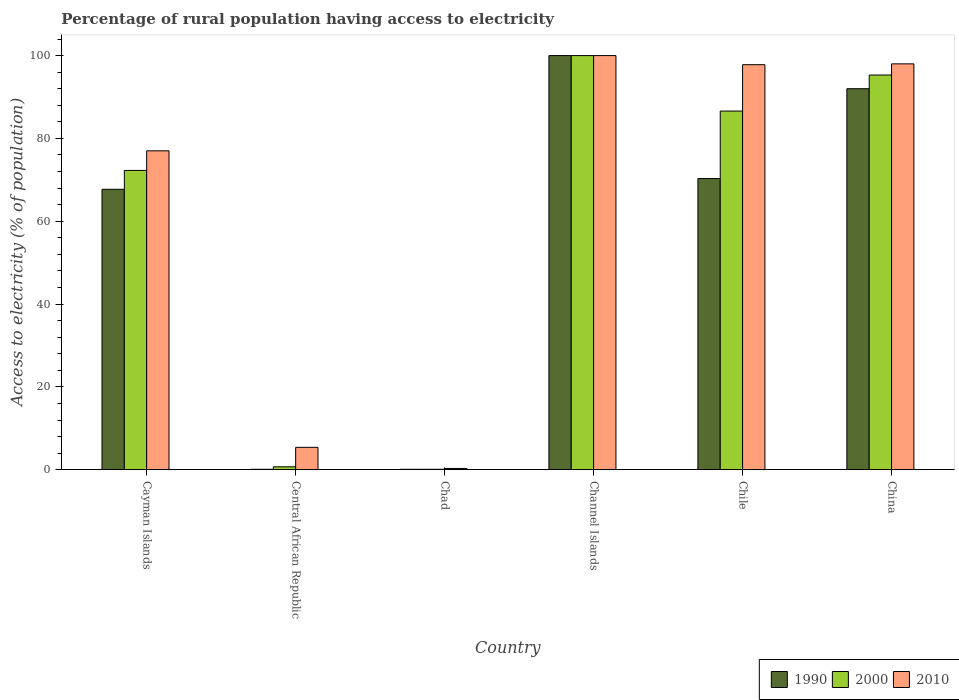How many different coloured bars are there?
Offer a very short reply. 3. How many groups of bars are there?
Make the answer very short. 6. How many bars are there on the 5th tick from the right?
Provide a succinct answer. 3. What is the label of the 1st group of bars from the left?
Keep it short and to the point. Cayman Islands. In how many cases, is the number of bars for a given country not equal to the number of legend labels?
Provide a succinct answer. 0. What is the percentage of rural population having access to electricity in 2000 in Cayman Islands?
Your response must be concise. 72.27. Across all countries, what is the maximum percentage of rural population having access to electricity in 2010?
Ensure brevity in your answer.  100. Across all countries, what is the minimum percentage of rural population having access to electricity in 2000?
Provide a short and direct response. 0.1. In which country was the percentage of rural population having access to electricity in 1990 maximum?
Your answer should be compact. Channel Islands. In which country was the percentage of rural population having access to electricity in 2010 minimum?
Make the answer very short. Chad. What is the total percentage of rural population having access to electricity in 2000 in the graph?
Your answer should be very brief. 354.97. What is the difference between the percentage of rural population having access to electricity in 1990 in Chile and the percentage of rural population having access to electricity in 2010 in Cayman Islands?
Offer a very short reply. -6.7. What is the average percentage of rural population having access to electricity in 2010 per country?
Offer a very short reply. 63.08. What is the difference between the percentage of rural population having access to electricity of/in 2010 and percentage of rural population having access to electricity of/in 2000 in Chad?
Offer a terse response. 0.2. In how many countries, is the percentage of rural population having access to electricity in 2010 greater than 56 %?
Keep it short and to the point. 4. What is the ratio of the percentage of rural population having access to electricity in 2010 in Cayman Islands to that in China?
Your answer should be very brief. 0.79. Is the percentage of rural population having access to electricity in 2000 in Chad less than that in Channel Islands?
Offer a terse response. Yes. Is the difference between the percentage of rural population having access to electricity in 2010 in Chile and China greater than the difference between the percentage of rural population having access to electricity in 2000 in Chile and China?
Your response must be concise. Yes. What is the difference between the highest and the second highest percentage of rural population having access to electricity in 2000?
Your response must be concise. 13.4. What is the difference between the highest and the lowest percentage of rural population having access to electricity in 2010?
Provide a succinct answer. 99.7. In how many countries, is the percentage of rural population having access to electricity in 2010 greater than the average percentage of rural population having access to electricity in 2010 taken over all countries?
Provide a short and direct response. 4. What does the 2nd bar from the left in Chad represents?
Provide a short and direct response. 2000. Is it the case that in every country, the sum of the percentage of rural population having access to electricity in 1990 and percentage of rural population having access to electricity in 2000 is greater than the percentage of rural population having access to electricity in 2010?
Make the answer very short. No. Does the graph contain any zero values?
Offer a very short reply. No. Where does the legend appear in the graph?
Give a very brief answer. Bottom right. What is the title of the graph?
Your response must be concise. Percentage of rural population having access to electricity. Does "1994" appear as one of the legend labels in the graph?
Your response must be concise. No. What is the label or title of the X-axis?
Provide a short and direct response. Country. What is the label or title of the Y-axis?
Offer a terse response. Access to electricity (% of population). What is the Access to electricity (% of population) of 1990 in Cayman Islands?
Your response must be concise. 67.71. What is the Access to electricity (% of population) in 2000 in Cayman Islands?
Provide a succinct answer. 72.27. What is the Access to electricity (% of population) of 2010 in Cayman Islands?
Your answer should be very brief. 77. What is the Access to electricity (% of population) in 2000 in Central African Republic?
Your answer should be very brief. 0.7. What is the Access to electricity (% of population) in 2010 in Central African Republic?
Offer a terse response. 5.4. What is the Access to electricity (% of population) of 1990 in Chad?
Make the answer very short. 0.1. What is the Access to electricity (% of population) in 2000 in Chad?
Your answer should be compact. 0.1. What is the Access to electricity (% of population) of 2010 in Chad?
Your response must be concise. 0.3. What is the Access to electricity (% of population) in 2000 in Channel Islands?
Give a very brief answer. 100. What is the Access to electricity (% of population) of 1990 in Chile?
Keep it short and to the point. 70.3. What is the Access to electricity (% of population) of 2000 in Chile?
Offer a very short reply. 86.6. What is the Access to electricity (% of population) in 2010 in Chile?
Your response must be concise. 97.8. What is the Access to electricity (% of population) in 1990 in China?
Provide a short and direct response. 92. What is the Access to electricity (% of population) of 2000 in China?
Your answer should be compact. 95.3. Across all countries, what is the maximum Access to electricity (% of population) in 2010?
Give a very brief answer. 100. Across all countries, what is the minimum Access to electricity (% of population) of 2000?
Provide a succinct answer. 0.1. Across all countries, what is the minimum Access to electricity (% of population) in 2010?
Offer a very short reply. 0.3. What is the total Access to electricity (% of population) of 1990 in the graph?
Give a very brief answer. 330.21. What is the total Access to electricity (% of population) of 2000 in the graph?
Your answer should be compact. 354.96. What is the total Access to electricity (% of population) of 2010 in the graph?
Keep it short and to the point. 378.5. What is the difference between the Access to electricity (% of population) of 1990 in Cayman Islands and that in Central African Republic?
Make the answer very short. 67.61. What is the difference between the Access to electricity (% of population) of 2000 in Cayman Islands and that in Central African Republic?
Ensure brevity in your answer.  71.56. What is the difference between the Access to electricity (% of population) in 2010 in Cayman Islands and that in Central African Republic?
Provide a succinct answer. 71.6. What is the difference between the Access to electricity (% of population) in 1990 in Cayman Islands and that in Chad?
Your answer should be compact. 67.61. What is the difference between the Access to electricity (% of population) in 2000 in Cayman Islands and that in Chad?
Offer a very short reply. 72.17. What is the difference between the Access to electricity (% of population) in 2010 in Cayman Islands and that in Chad?
Give a very brief answer. 76.7. What is the difference between the Access to electricity (% of population) of 1990 in Cayman Islands and that in Channel Islands?
Your answer should be very brief. -32.29. What is the difference between the Access to electricity (% of population) of 2000 in Cayman Islands and that in Channel Islands?
Your answer should be very brief. -27.73. What is the difference between the Access to electricity (% of population) in 2010 in Cayman Islands and that in Channel Islands?
Offer a very short reply. -23. What is the difference between the Access to electricity (% of population) of 1990 in Cayman Islands and that in Chile?
Your response must be concise. -2.59. What is the difference between the Access to electricity (% of population) in 2000 in Cayman Islands and that in Chile?
Your response must be concise. -14.34. What is the difference between the Access to electricity (% of population) in 2010 in Cayman Islands and that in Chile?
Your answer should be compact. -20.8. What is the difference between the Access to electricity (% of population) in 1990 in Cayman Islands and that in China?
Your answer should be compact. -24.29. What is the difference between the Access to electricity (% of population) of 2000 in Cayman Islands and that in China?
Provide a succinct answer. -23.04. What is the difference between the Access to electricity (% of population) of 2010 in Cayman Islands and that in China?
Make the answer very short. -21. What is the difference between the Access to electricity (% of population) of 2000 in Central African Republic and that in Chad?
Provide a succinct answer. 0.6. What is the difference between the Access to electricity (% of population) of 2010 in Central African Republic and that in Chad?
Your answer should be very brief. 5.1. What is the difference between the Access to electricity (% of population) in 1990 in Central African Republic and that in Channel Islands?
Your answer should be compact. -99.9. What is the difference between the Access to electricity (% of population) in 2000 in Central African Republic and that in Channel Islands?
Provide a short and direct response. -99.3. What is the difference between the Access to electricity (% of population) in 2010 in Central African Republic and that in Channel Islands?
Make the answer very short. -94.6. What is the difference between the Access to electricity (% of population) of 1990 in Central African Republic and that in Chile?
Offer a very short reply. -70.2. What is the difference between the Access to electricity (% of population) of 2000 in Central African Republic and that in Chile?
Ensure brevity in your answer.  -85.9. What is the difference between the Access to electricity (% of population) in 2010 in Central African Republic and that in Chile?
Your answer should be compact. -92.4. What is the difference between the Access to electricity (% of population) in 1990 in Central African Republic and that in China?
Ensure brevity in your answer.  -91.9. What is the difference between the Access to electricity (% of population) in 2000 in Central African Republic and that in China?
Ensure brevity in your answer.  -94.6. What is the difference between the Access to electricity (% of population) in 2010 in Central African Republic and that in China?
Give a very brief answer. -92.6. What is the difference between the Access to electricity (% of population) in 1990 in Chad and that in Channel Islands?
Your answer should be very brief. -99.9. What is the difference between the Access to electricity (% of population) in 2000 in Chad and that in Channel Islands?
Your answer should be compact. -99.9. What is the difference between the Access to electricity (% of population) in 2010 in Chad and that in Channel Islands?
Keep it short and to the point. -99.7. What is the difference between the Access to electricity (% of population) in 1990 in Chad and that in Chile?
Offer a terse response. -70.2. What is the difference between the Access to electricity (% of population) of 2000 in Chad and that in Chile?
Keep it short and to the point. -86.5. What is the difference between the Access to electricity (% of population) in 2010 in Chad and that in Chile?
Your response must be concise. -97.5. What is the difference between the Access to electricity (% of population) in 1990 in Chad and that in China?
Provide a succinct answer. -91.9. What is the difference between the Access to electricity (% of population) of 2000 in Chad and that in China?
Offer a terse response. -95.2. What is the difference between the Access to electricity (% of population) in 2010 in Chad and that in China?
Provide a succinct answer. -97.7. What is the difference between the Access to electricity (% of population) in 1990 in Channel Islands and that in Chile?
Your response must be concise. 29.7. What is the difference between the Access to electricity (% of population) of 2000 in Channel Islands and that in Chile?
Keep it short and to the point. 13.4. What is the difference between the Access to electricity (% of population) of 2000 in Channel Islands and that in China?
Keep it short and to the point. 4.7. What is the difference between the Access to electricity (% of population) in 2010 in Channel Islands and that in China?
Your answer should be compact. 2. What is the difference between the Access to electricity (% of population) in 1990 in Chile and that in China?
Your answer should be compact. -21.7. What is the difference between the Access to electricity (% of population) of 2000 in Chile and that in China?
Your answer should be compact. -8.7. What is the difference between the Access to electricity (% of population) in 1990 in Cayman Islands and the Access to electricity (% of population) in 2000 in Central African Republic?
Provide a short and direct response. 67.01. What is the difference between the Access to electricity (% of population) in 1990 in Cayman Islands and the Access to electricity (% of population) in 2010 in Central African Republic?
Your answer should be compact. 62.31. What is the difference between the Access to electricity (% of population) in 2000 in Cayman Islands and the Access to electricity (% of population) in 2010 in Central African Republic?
Make the answer very short. 66.86. What is the difference between the Access to electricity (% of population) in 1990 in Cayman Islands and the Access to electricity (% of population) in 2000 in Chad?
Offer a very short reply. 67.61. What is the difference between the Access to electricity (% of population) of 1990 in Cayman Islands and the Access to electricity (% of population) of 2010 in Chad?
Your answer should be compact. 67.41. What is the difference between the Access to electricity (% of population) of 2000 in Cayman Islands and the Access to electricity (% of population) of 2010 in Chad?
Make the answer very short. 71.97. What is the difference between the Access to electricity (% of population) of 1990 in Cayman Islands and the Access to electricity (% of population) of 2000 in Channel Islands?
Give a very brief answer. -32.29. What is the difference between the Access to electricity (% of population) in 1990 in Cayman Islands and the Access to electricity (% of population) in 2010 in Channel Islands?
Offer a terse response. -32.29. What is the difference between the Access to electricity (% of population) in 2000 in Cayman Islands and the Access to electricity (% of population) in 2010 in Channel Islands?
Your answer should be very brief. -27.73. What is the difference between the Access to electricity (% of population) in 1990 in Cayman Islands and the Access to electricity (% of population) in 2000 in Chile?
Keep it short and to the point. -18.89. What is the difference between the Access to electricity (% of population) of 1990 in Cayman Islands and the Access to electricity (% of population) of 2010 in Chile?
Provide a short and direct response. -30.09. What is the difference between the Access to electricity (% of population) of 2000 in Cayman Islands and the Access to electricity (% of population) of 2010 in Chile?
Your answer should be very brief. -25.54. What is the difference between the Access to electricity (% of population) in 1990 in Cayman Islands and the Access to electricity (% of population) in 2000 in China?
Give a very brief answer. -27.59. What is the difference between the Access to electricity (% of population) of 1990 in Cayman Islands and the Access to electricity (% of population) of 2010 in China?
Your response must be concise. -30.29. What is the difference between the Access to electricity (% of population) of 2000 in Cayman Islands and the Access to electricity (% of population) of 2010 in China?
Keep it short and to the point. -25.73. What is the difference between the Access to electricity (% of population) of 1990 in Central African Republic and the Access to electricity (% of population) of 2000 in Chad?
Provide a succinct answer. 0. What is the difference between the Access to electricity (% of population) in 1990 in Central African Republic and the Access to electricity (% of population) in 2010 in Chad?
Ensure brevity in your answer.  -0.2. What is the difference between the Access to electricity (% of population) in 2000 in Central African Republic and the Access to electricity (% of population) in 2010 in Chad?
Provide a short and direct response. 0.4. What is the difference between the Access to electricity (% of population) of 1990 in Central African Republic and the Access to electricity (% of population) of 2000 in Channel Islands?
Offer a very short reply. -99.9. What is the difference between the Access to electricity (% of population) of 1990 in Central African Republic and the Access to electricity (% of population) of 2010 in Channel Islands?
Give a very brief answer. -99.9. What is the difference between the Access to electricity (% of population) in 2000 in Central African Republic and the Access to electricity (% of population) in 2010 in Channel Islands?
Ensure brevity in your answer.  -99.3. What is the difference between the Access to electricity (% of population) in 1990 in Central African Republic and the Access to electricity (% of population) in 2000 in Chile?
Provide a short and direct response. -86.5. What is the difference between the Access to electricity (% of population) of 1990 in Central African Republic and the Access to electricity (% of population) of 2010 in Chile?
Offer a very short reply. -97.7. What is the difference between the Access to electricity (% of population) in 2000 in Central African Republic and the Access to electricity (% of population) in 2010 in Chile?
Offer a terse response. -97.1. What is the difference between the Access to electricity (% of population) in 1990 in Central African Republic and the Access to electricity (% of population) in 2000 in China?
Offer a very short reply. -95.2. What is the difference between the Access to electricity (% of population) of 1990 in Central African Republic and the Access to electricity (% of population) of 2010 in China?
Offer a very short reply. -97.9. What is the difference between the Access to electricity (% of population) of 2000 in Central African Republic and the Access to electricity (% of population) of 2010 in China?
Ensure brevity in your answer.  -97.3. What is the difference between the Access to electricity (% of population) of 1990 in Chad and the Access to electricity (% of population) of 2000 in Channel Islands?
Give a very brief answer. -99.9. What is the difference between the Access to electricity (% of population) in 1990 in Chad and the Access to electricity (% of population) in 2010 in Channel Islands?
Your answer should be compact. -99.9. What is the difference between the Access to electricity (% of population) of 2000 in Chad and the Access to electricity (% of population) of 2010 in Channel Islands?
Your answer should be compact. -99.9. What is the difference between the Access to electricity (% of population) in 1990 in Chad and the Access to electricity (% of population) in 2000 in Chile?
Give a very brief answer. -86.5. What is the difference between the Access to electricity (% of population) in 1990 in Chad and the Access to electricity (% of population) in 2010 in Chile?
Offer a very short reply. -97.7. What is the difference between the Access to electricity (% of population) in 2000 in Chad and the Access to electricity (% of population) in 2010 in Chile?
Your response must be concise. -97.7. What is the difference between the Access to electricity (% of population) in 1990 in Chad and the Access to electricity (% of population) in 2000 in China?
Your response must be concise. -95.2. What is the difference between the Access to electricity (% of population) of 1990 in Chad and the Access to electricity (% of population) of 2010 in China?
Keep it short and to the point. -97.9. What is the difference between the Access to electricity (% of population) in 2000 in Chad and the Access to electricity (% of population) in 2010 in China?
Provide a succinct answer. -97.9. What is the difference between the Access to electricity (% of population) in 1990 in Channel Islands and the Access to electricity (% of population) in 2010 in Chile?
Give a very brief answer. 2.2. What is the difference between the Access to electricity (% of population) in 1990 in Channel Islands and the Access to electricity (% of population) in 2000 in China?
Keep it short and to the point. 4.7. What is the difference between the Access to electricity (% of population) in 2000 in Channel Islands and the Access to electricity (% of population) in 2010 in China?
Keep it short and to the point. 2. What is the difference between the Access to electricity (% of population) of 1990 in Chile and the Access to electricity (% of population) of 2000 in China?
Make the answer very short. -25. What is the difference between the Access to electricity (% of population) in 1990 in Chile and the Access to electricity (% of population) in 2010 in China?
Your response must be concise. -27.7. What is the difference between the Access to electricity (% of population) in 2000 in Chile and the Access to electricity (% of population) in 2010 in China?
Your response must be concise. -11.4. What is the average Access to electricity (% of population) of 1990 per country?
Offer a terse response. 55.04. What is the average Access to electricity (% of population) of 2000 per country?
Your answer should be compact. 59.16. What is the average Access to electricity (% of population) of 2010 per country?
Your response must be concise. 63.08. What is the difference between the Access to electricity (% of population) in 1990 and Access to electricity (% of population) in 2000 in Cayman Islands?
Make the answer very short. -4.55. What is the difference between the Access to electricity (% of population) in 1990 and Access to electricity (% of population) in 2010 in Cayman Islands?
Offer a terse response. -9.29. What is the difference between the Access to electricity (% of population) in 2000 and Access to electricity (% of population) in 2010 in Cayman Islands?
Your answer should be very brief. -4.74. What is the difference between the Access to electricity (% of population) of 1990 and Access to electricity (% of population) of 2000 in Central African Republic?
Provide a short and direct response. -0.6. What is the difference between the Access to electricity (% of population) of 1990 and Access to electricity (% of population) of 2010 in Central African Republic?
Provide a succinct answer. -5.3. What is the difference between the Access to electricity (% of population) in 1990 and Access to electricity (% of population) in 2000 in Chad?
Ensure brevity in your answer.  0. What is the difference between the Access to electricity (% of population) of 2000 and Access to electricity (% of population) of 2010 in Chad?
Your answer should be compact. -0.2. What is the difference between the Access to electricity (% of population) in 1990 and Access to electricity (% of population) in 2000 in Channel Islands?
Give a very brief answer. 0. What is the difference between the Access to electricity (% of population) in 1990 and Access to electricity (% of population) in 2010 in Channel Islands?
Provide a short and direct response. 0. What is the difference between the Access to electricity (% of population) in 1990 and Access to electricity (% of population) in 2000 in Chile?
Make the answer very short. -16.3. What is the difference between the Access to electricity (% of population) of 1990 and Access to electricity (% of population) of 2010 in Chile?
Offer a terse response. -27.5. What is the difference between the Access to electricity (% of population) in 2000 and Access to electricity (% of population) in 2010 in Chile?
Ensure brevity in your answer.  -11.2. What is the difference between the Access to electricity (% of population) of 1990 and Access to electricity (% of population) of 2000 in China?
Offer a terse response. -3.3. What is the difference between the Access to electricity (% of population) of 1990 and Access to electricity (% of population) of 2010 in China?
Keep it short and to the point. -6. What is the ratio of the Access to electricity (% of population) in 1990 in Cayman Islands to that in Central African Republic?
Offer a terse response. 677.11. What is the ratio of the Access to electricity (% of population) of 2000 in Cayman Islands to that in Central African Republic?
Your response must be concise. 103.24. What is the ratio of the Access to electricity (% of population) of 2010 in Cayman Islands to that in Central African Republic?
Keep it short and to the point. 14.26. What is the ratio of the Access to electricity (% of population) of 1990 in Cayman Islands to that in Chad?
Ensure brevity in your answer.  677.11. What is the ratio of the Access to electricity (% of population) of 2000 in Cayman Islands to that in Chad?
Provide a short and direct response. 722.65. What is the ratio of the Access to electricity (% of population) in 2010 in Cayman Islands to that in Chad?
Provide a short and direct response. 256.67. What is the ratio of the Access to electricity (% of population) of 1990 in Cayman Islands to that in Channel Islands?
Ensure brevity in your answer.  0.68. What is the ratio of the Access to electricity (% of population) of 2000 in Cayman Islands to that in Channel Islands?
Offer a very short reply. 0.72. What is the ratio of the Access to electricity (% of population) of 2010 in Cayman Islands to that in Channel Islands?
Offer a terse response. 0.77. What is the ratio of the Access to electricity (% of population) of 1990 in Cayman Islands to that in Chile?
Your answer should be very brief. 0.96. What is the ratio of the Access to electricity (% of population) of 2000 in Cayman Islands to that in Chile?
Your answer should be very brief. 0.83. What is the ratio of the Access to electricity (% of population) in 2010 in Cayman Islands to that in Chile?
Give a very brief answer. 0.79. What is the ratio of the Access to electricity (% of population) in 1990 in Cayman Islands to that in China?
Keep it short and to the point. 0.74. What is the ratio of the Access to electricity (% of population) of 2000 in Cayman Islands to that in China?
Give a very brief answer. 0.76. What is the ratio of the Access to electricity (% of population) of 2010 in Cayman Islands to that in China?
Offer a very short reply. 0.79. What is the ratio of the Access to electricity (% of population) of 2000 in Central African Republic to that in Chad?
Provide a short and direct response. 7. What is the ratio of the Access to electricity (% of population) in 1990 in Central African Republic to that in Channel Islands?
Offer a terse response. 0. What is the ratio of the Access to electricity (% of population) in 2000 in Central African Republic to that in Channel Islands?
Your answer should be compact. 0.01. What is the ratio of the Access to electricity (% of population) in 2010 in Central African Republic to that in Channel Islands?
Provide a succinct answer. 0.05. What is the ratio of the Access to electricity (% of population) of 1990 in Central African Republic to that in Chile?
Your response must be concise. 0. What is the ratio of the Access to electricity (% of population) of 2000 in Central African Republic to that in Chile?
Provide a succinct answer. 0.01. What is the ratio of the Access to electricity (% of population) of 2010 in Central African Republic to that in Chile?
Provide a succinct answer. 0.06. What is the ratio of the Access to electricity (% of population) in 1990 in Central African Republic to that in China?
Your answer should be very brief. 0. What is the ratio of the Access to electricity (% of population) of 2000 in Central African Republic to that in China?
Keep it short and to the point. 0.01. What is the ratio of the Access to electricity (% of population) in 2010 in Central African Republic to that in China?
Give a very brief answer. 0.06. What is the ratio of the Access to electricity (% of population) in 1990 in Chad to that in Channel Islands?
Offer a terse response. 0. What is the ratio of the Access to electricity (% of population) of 2000 in Chad to that in Channel Islands?
Your answer should be compact. 0. What is the ratio of the Access to electricity (% of population) in 2010 in Chad to that in Channel Islands?
Your answer should be very brief. 0. What is the ratio of the Access to electricity (% of population) of 1990 in Chad to that in Chile?
Your answer should be very brief. 0. What is the ratio of the Access to electricity (% of population) in 2000 in Chad to that in Chile?
Give a very brief answer. 0. What is the ratio of the Access to electricity (% of population) in 2010 in Chad to that in Chile?
Offer a very short reply. 0. What is the ratio of the Access to electricity (% of population) of 1990 in Chad to that in China?
Make the answer very short. 0. What is the ratio of the Access to electricity (% of population) in 2000 in Chad to that in China?
Offer a very short reply. 0. What is the ratio of the Access to electricity (% of population) in 2010 in Chad to that in China?
Keep it short and to the point. 0. What is the ratio of the Access to electricity (% of population) in 1990 in Channel Islands to that in Chile?
Your answer should be very brief. 1.42. What is the ratio of the Access to electricity (% of population) of 2000 in Channel Islands to that in Chile?
Offer a very short reply. 1.15. What is the ratio of the Access to electricity (% of population) in 2010 in Channel Islands to that in Chile?
Your response must be concise. 1.02. What is the ratio of the Access to electricity (% of population) in 1990 in Channel Islands to that in China?
Your answer should be compact. 1.09. What is the ratio of the Access to electricity (% of population) of 2000 in Channel Islands to that in China?
Make the answer very short. 1.05. What is the ratio of the Access to electricity (% of population) of 2010 in Channel Islands to that in China?
Offer a terse response. 1.02. What is the ratio of the Access to electricity (% of population) of 1990 in Chile to that in China?
Offer a very short reply. 0.76. What is the ratio of the Access to electricity (% of population) of 2000 in Chile to that in China?
Provide a short and direct response. 0.91. What is the ratio of the Access to electricity (% of population) of 2010 in Chile to that in China?
Keep it short and to the point. 1. What is the difference between the highest and the second highest Access to electricity (% of population) of 2000?
Offer a terse response. 4.7. What is the difference between the highest and the second highest Access to electricity (% of population) of 2010?
Provide a succinct answer. 2. What is the difference between the highest and the lowest Access to electricity (% of population) in 1990?
Provide a short and direct response. 99.9. What is the difference between the highest and the lowest Access to electricity (% of population) in 2000?
Your response must be concise. 99.9. What is the difference between the highest and the lowest Access to electricity (% of population) of 2010?
Keep it short and to the point. 99.7. 